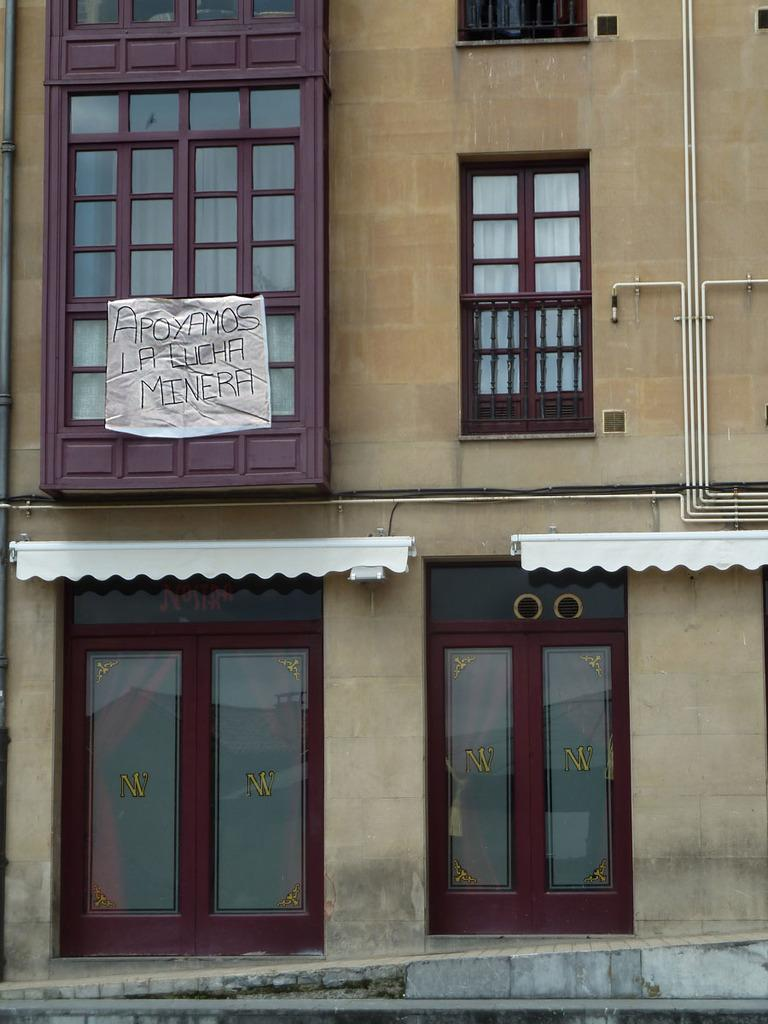What type of structure is present in the image? There is a building in the image. What features can be observed on the building? The building has windows and a glass door. Is there any additional signage or decoration on the building? Yes, there is a banner on the building. What flavor of club can be seen in the image? There is no club or flavor mentioned in the image; it features a building with windows, a glass door, and a banner. 